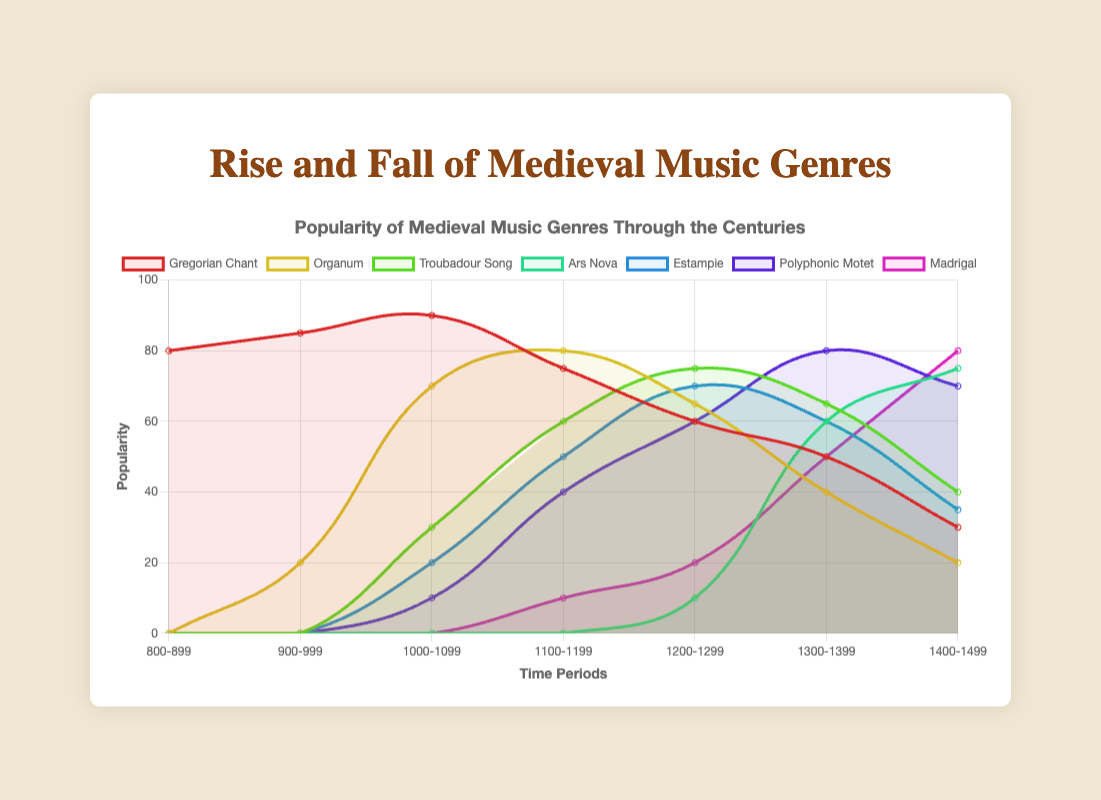Which genre has the highest peak in popularity? By examining the plot, we can look for the genre with the highest point on the popularity scale (y-axis). "Gregorian Chant" has the highest peak with a popularity of 90.
Answer: Gregorian Chant Between which time periods did Organum see the largest increase in popularity? By looking at the slope of the Organum line, the steepest climb is between "900-999" and "1000-1099," where it rose from 20 to 70.
Answer: 900-999 to 1000-1099 Which genres crossed each other’s popularity lines between the time periods "1200-1299" and "1300-1399"? Looking at the plot, "Ars Nova" crosses "Estampie", "Polyphonic Motet", and "Madrigal". Ars Nova rises to 60, while Estampie, and all the others drop or rise slower.
Answer: Ars Nova and Estampie Which genre maintained a consistently increasing trend throughout all time periods? By examining the trend lines, "Madrigal" consistently rises from 0 to 80 across all time periods without any decline.
Answer: Madrigal What is the popularity difference between Gregorian Chant and Polyphonic Motet in the period "1100-1199"? Looking at the "1100-1199" section of the figure, Gregorian Chant has a popularity of 75 and Polyphonic Motet has 40, so the difference is 75 - 40.
Answer: 35 In which period did Troubadour Song have its peak popularity? By checking the peak point of the Troubadour Song line, its peak popularity of 75 occurs in "1200-1299".
Answer: 1200-1299 What is the average popularity of Estampie across all time periods? Summing up Estampie's popularity values [0, 0, 20, 50, 70, 60, 35] gives 235. There are 7 periods, so the average is 235/7.
Answer: 33.57 Which two genres have their peak popularity in the time period "1300-1399"? By examining the points for "1300-1399", "Ars Nova" and "Polyphonic Motet" both peak with values of 60 and 80 respectively.
Answer: Ars Nova & Polyphonic Motet Which genre experienced the greatest decline after its peak? Observing the highest drop from peak value, "Gregorian Chant" dropped from 90 to 30, a decline of 60, the largest among the genres.
Answer: Gregorian Chant 